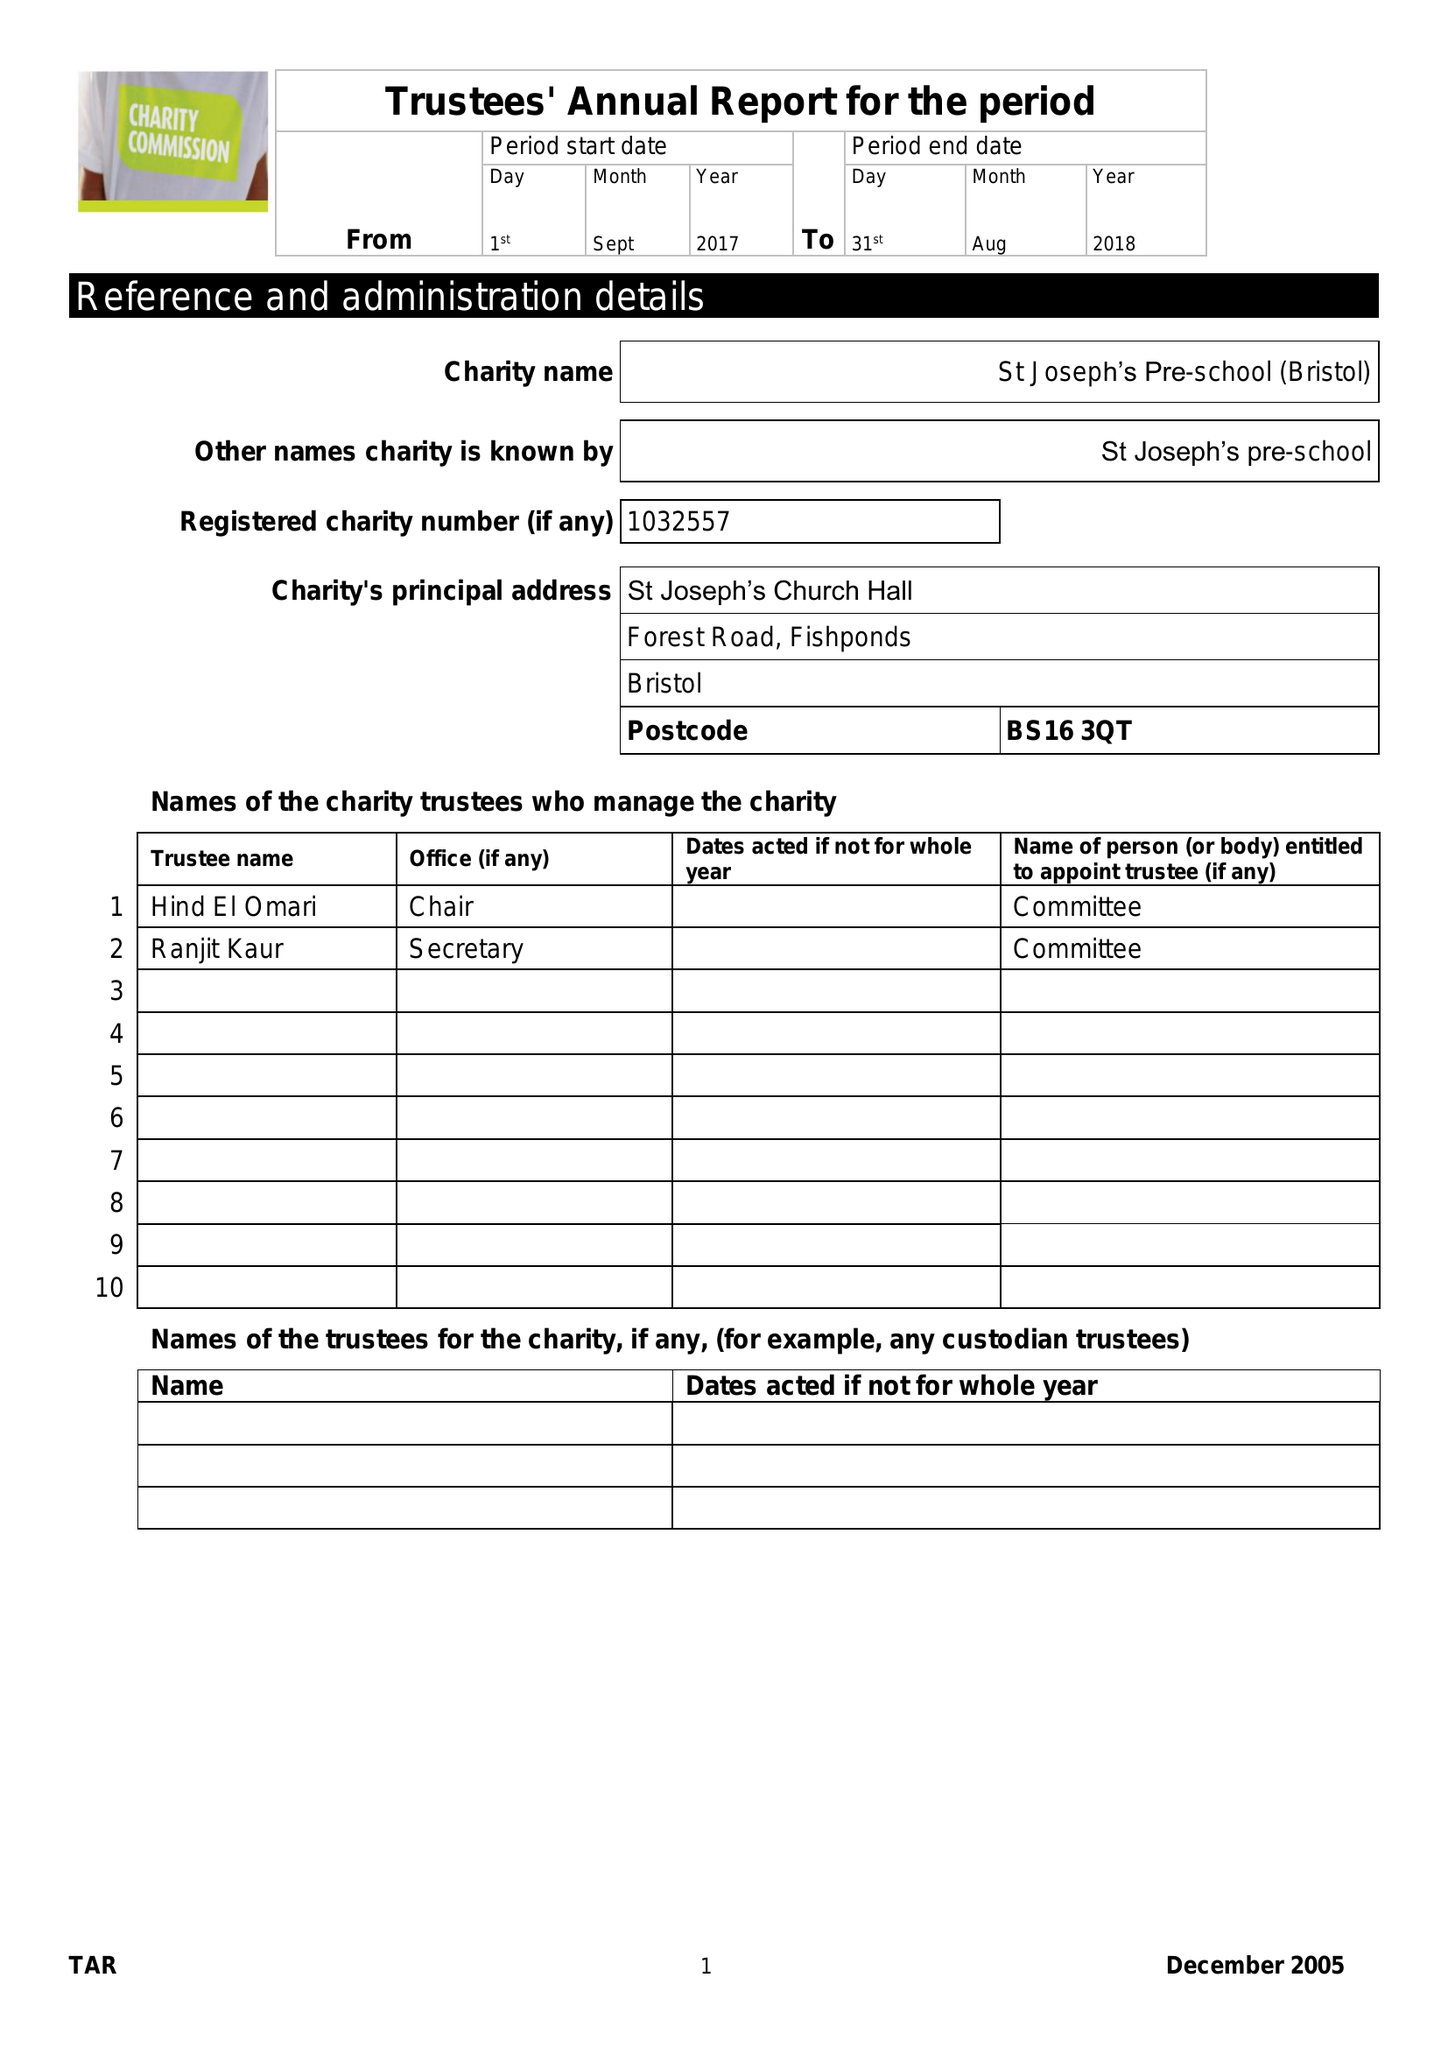What is the value for the address__street_line?
Answer the question using a single word or phrase. FOREST ROAD 